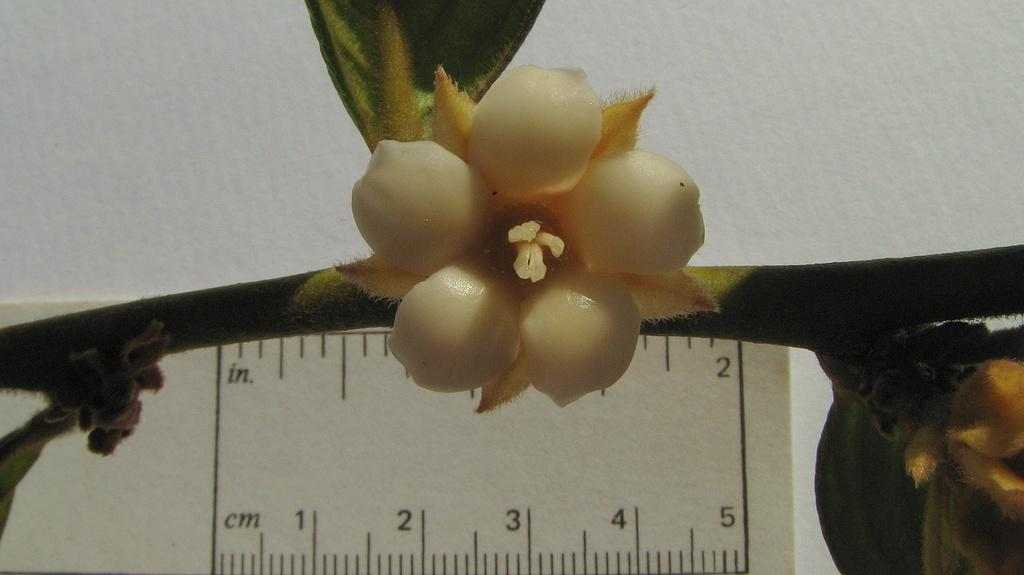What type of flower is in the picture? There is a moth orchid flower in the picture. What object is located at the bottom of the picture? There is a measuring device at the bottom of the picture. What can be seen in the background of the image? There appears to be a wall in the background of the image. What channel is the flower watching on TV in the image? There is no TV or channel present in the image; it only features a moth orchid flower, a measuring device, and a wall in the background. 